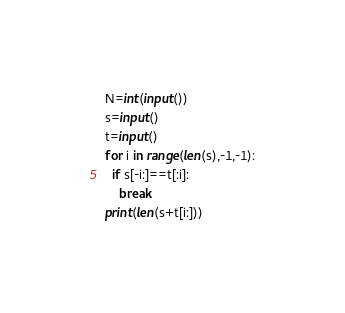Convert code to text. <code><loc_0><loc_0><loc_500><loc_500><_Python_>N=int(input())
s=input()
t=input()
for i in range(len(s),-1,-1):
  if s[-i:]==t[:i]:
    break
print(len(s+t[i:]))</code> 